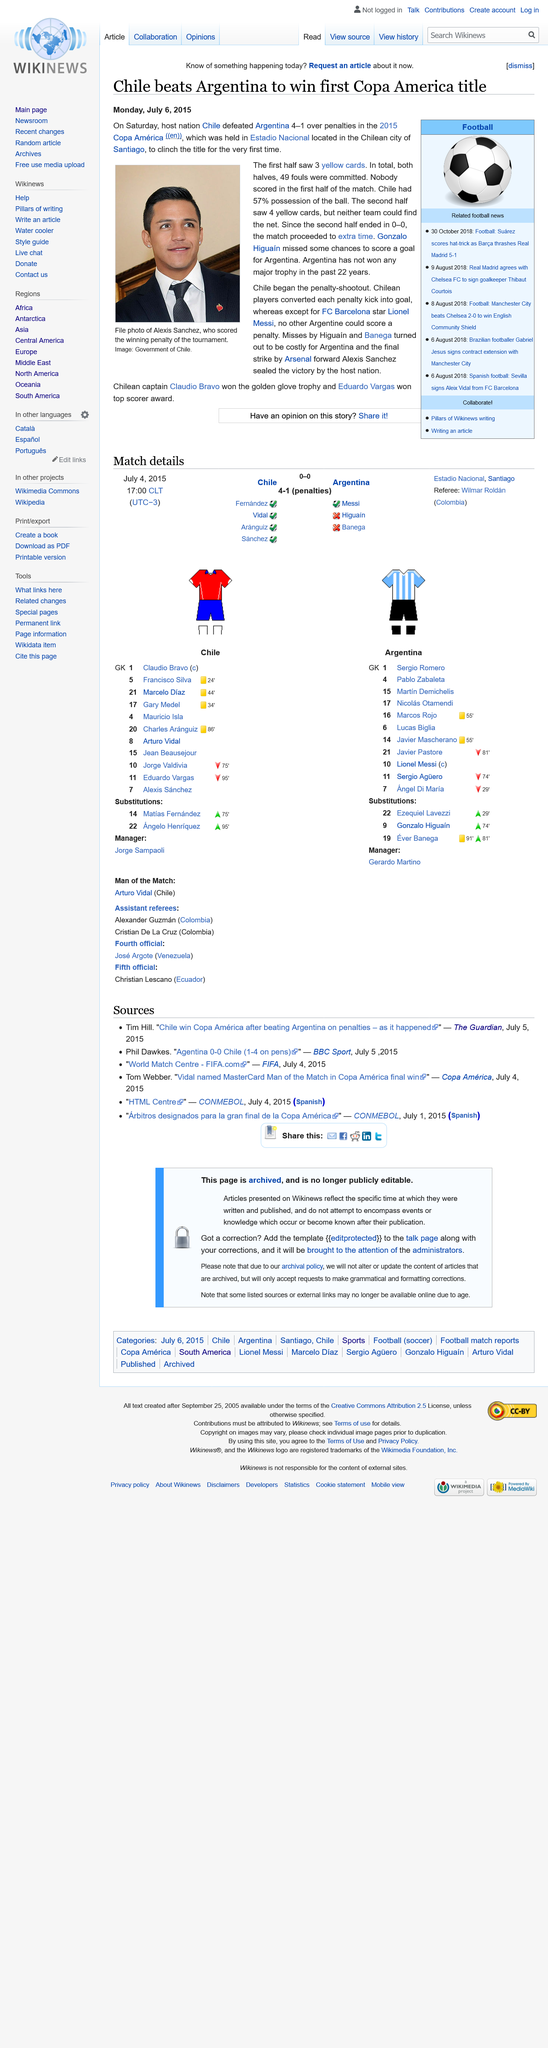Outline some significant characteristics in this image. In total, a total of 49 fouls were committed in both halves of the game. Chile, the host country, emerged victorious at the Copa America tournament by defeating Argentina, the defending champions, to secure their first title in the history of the competition. The 2015 Copa America was held in Estadio Nacional, a stadium located in the Chilean city of Santiago, where it was played in the Chilean capital city. 